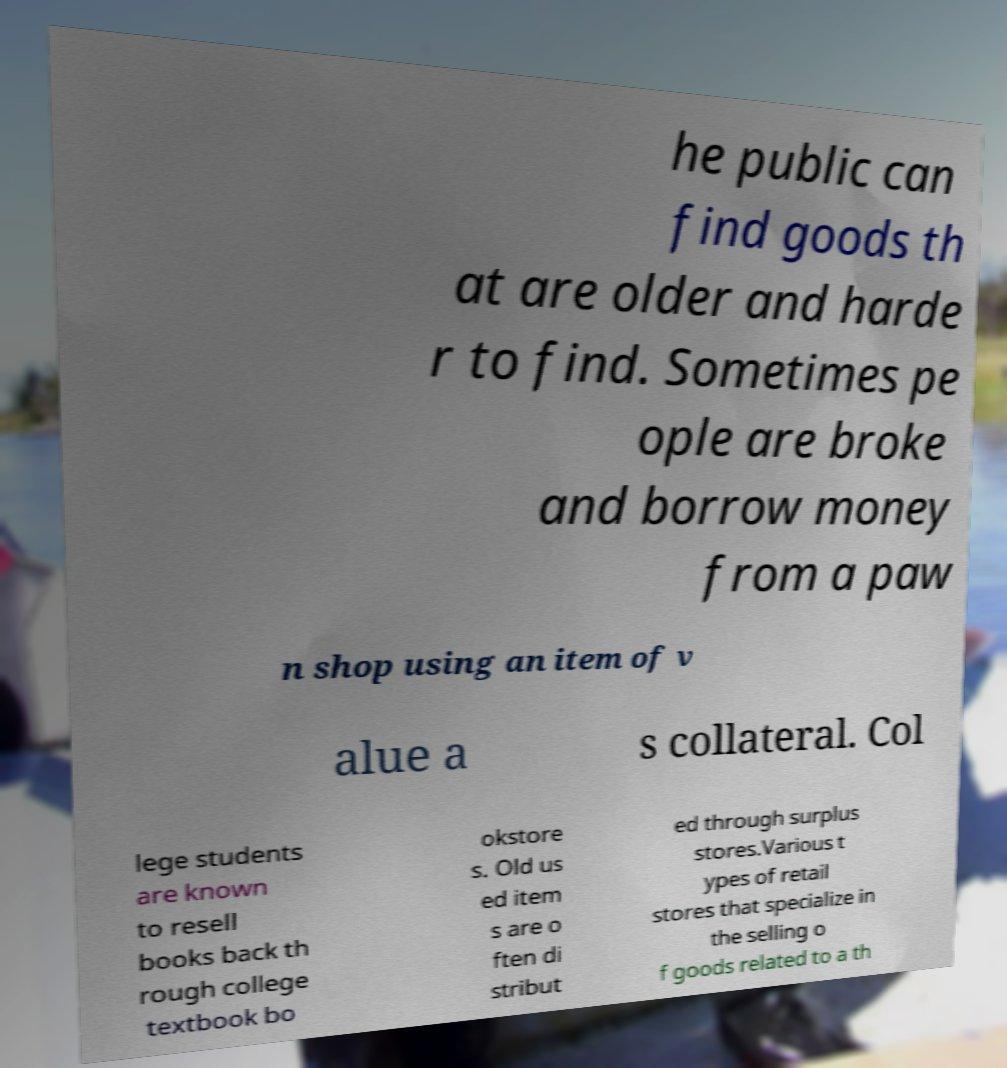Can you read and provide the text displayed in the image?This photo seems to have some interesting text. Can you extract and type it out for me? he public can find goods th at are older and harde r to find. Sometimes pe ople are broke and borrow money from a paw n shop using an item of v alue a s collateral. Col lege students are known to resell books back th rough college textbook bo okstore s. Old us ed item s are o ften di stribut ed through surplus stores.Various t ypes of retail stores that specialize in the selling o f goods related to a th 